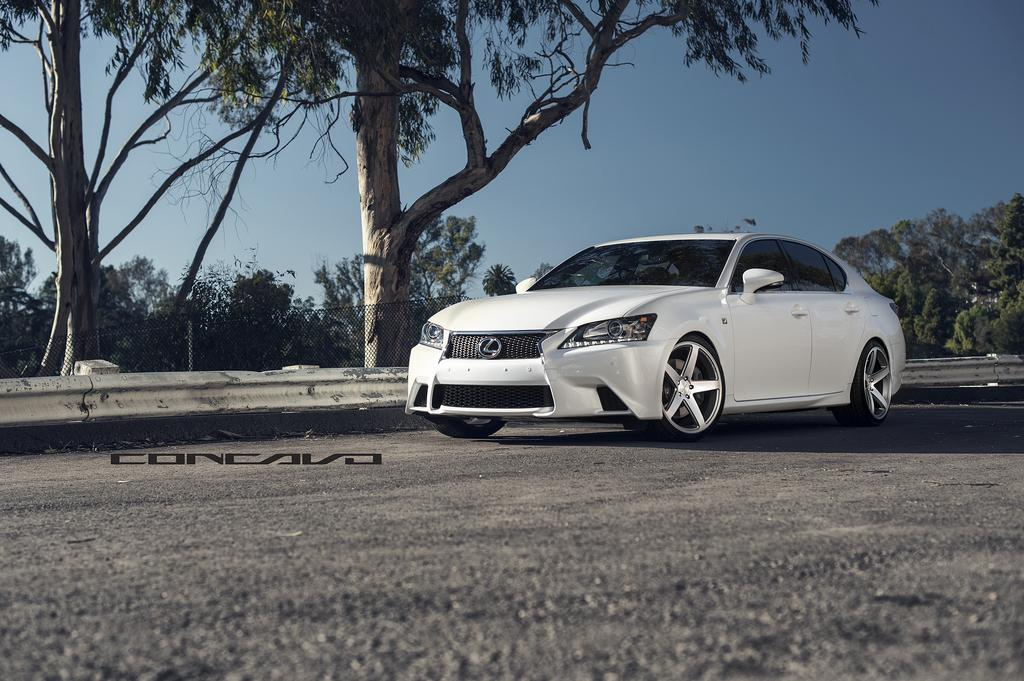What is the main subject of the image? There is a car on the road in the image. What can be seen in the background of the image? There are trees, plants, and grass. What part of the sky is visible in the image? The sky is visible in the top right corner of the image. Is there any text or logo on the image? Yes, there is a watermark on the left side of the image. What type of bottle can be seen in the hands of the friends in the image? There are no friends or bottles present in the image; it features a car on the road with a background of trees, plants, grass, and the sky. 